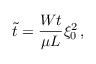<formula> <loc_0><loc_0><loc_500><loc_500>\tilde { t } = \frac { W t } { \mu L } \xi _ { 0 } ^ { 2 } \, ,</formula> 